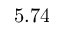Convert formula to latex. <formula><loc_0><loc_0><loc_500><loc_500>5 . 7 4</formula> 